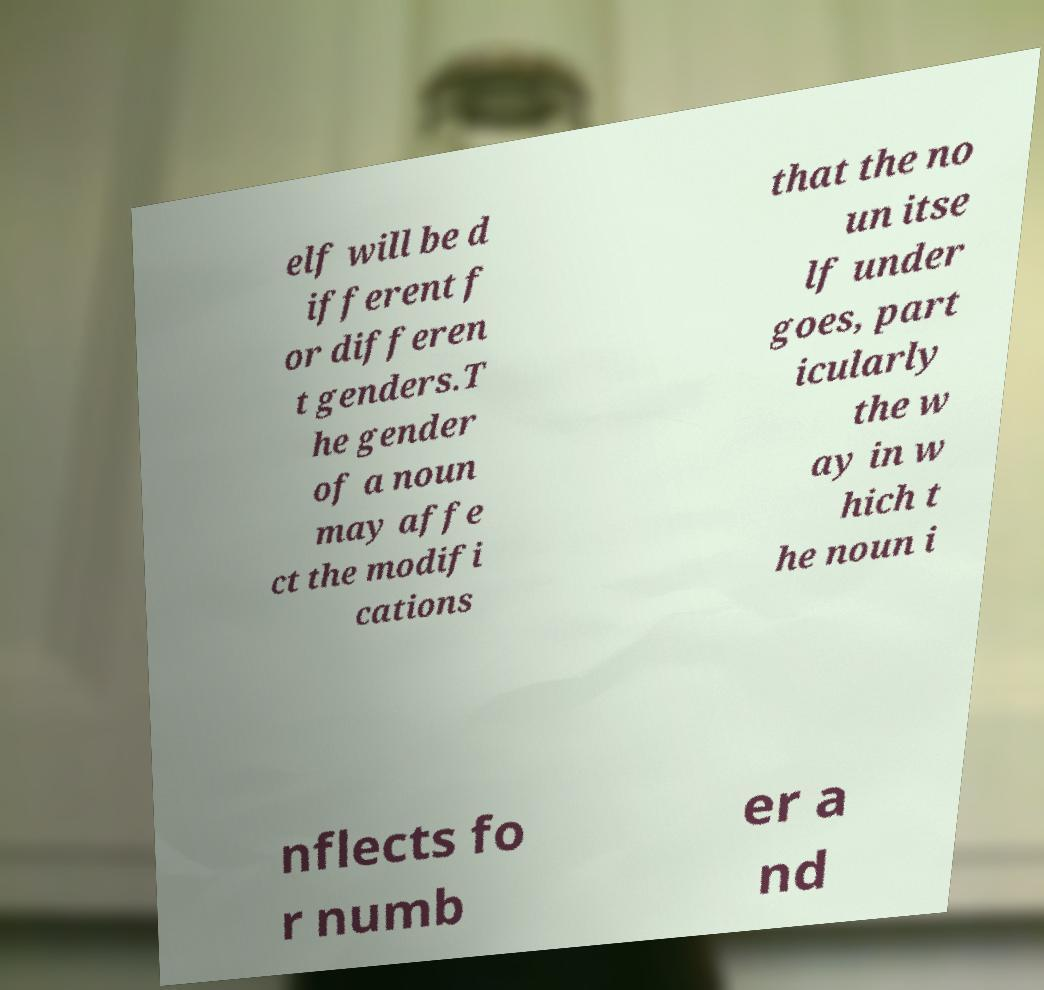Can you read and provide the text displayed in the image?This photo seems to have some interesting text. Can you extract and type it out for me? elf will be d ifferent f or differen t genders.T he gender of a noun may affe ct the modifi cations that the no un itse lf under goes, part icularly the w ay in w hich t he noun i nflects fo r numb er a nd 